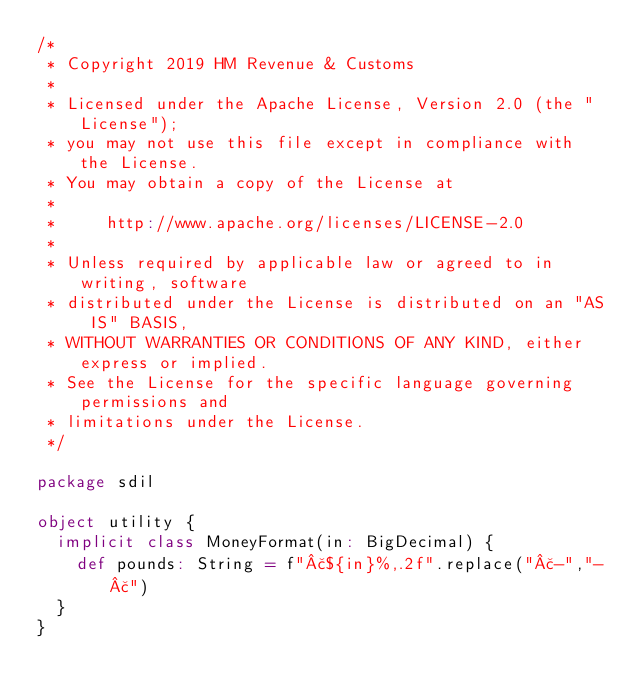Convert code to text. <code><loc_0><loc_0><loc_500><loc_500><_Scala_>/*
 * Copyright 2019 HM Revenue & Customs
 *
 * Licensed under the Apache License, Version 2.0 (the "License");
 * you may not use this file except in compliance with the License.
 * You may obtain a copy of the License at
 *
 *     http://www.apache.org/licenses/LICENSE-2.0
 *
 * Unless required by applicable law or agreed to in writing, software
 * distributed under the License is distributed on an "AS IS" BASIS,
 * WITHOUT WARRANTIES OR CONDITIONS OF ANY KIND, either express or implied.
 * See the License for the specific language governing permissions and
 * limitations under the License.
 */

package sdil

object utility {
  implicit class MoneyFormat(in: BigDecimal) {
    def pounds: String = f"£${in}%,.2f".replace("£-","-£")
  }
}

</code> 